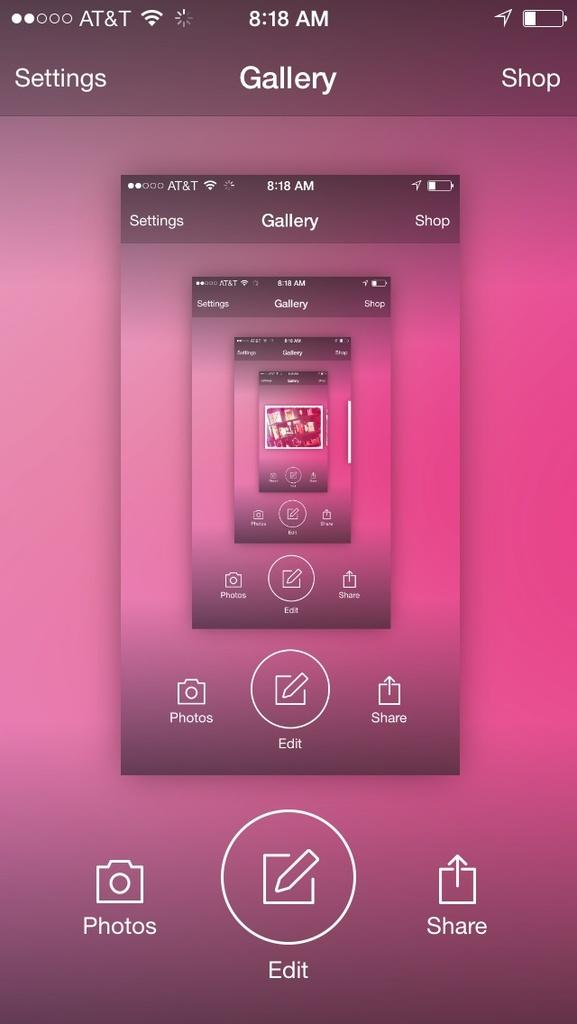<image>
Present a compact description of the photo's key features. A smart phone screen that shows settings, Gallery, and shop across the top and has several screens that get smaller inside of it. 